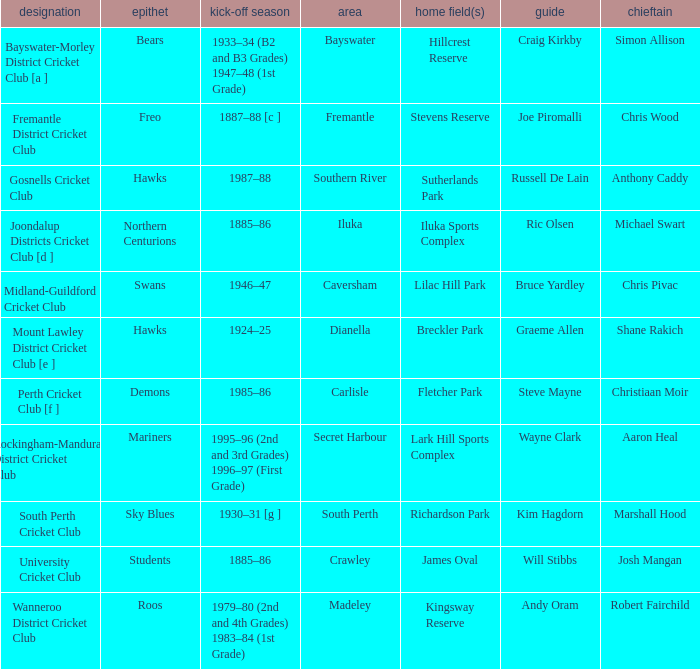What is the location for the club with the nickname the bears? Bayswater. 